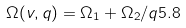<formula> <loc_0><loc_0><loc_500><loc_500>\Omega ( v , q ) = \Omega _ { 1 } + \Omega _ { 2 } \slash { q } { 5 . 8 }</formula> 